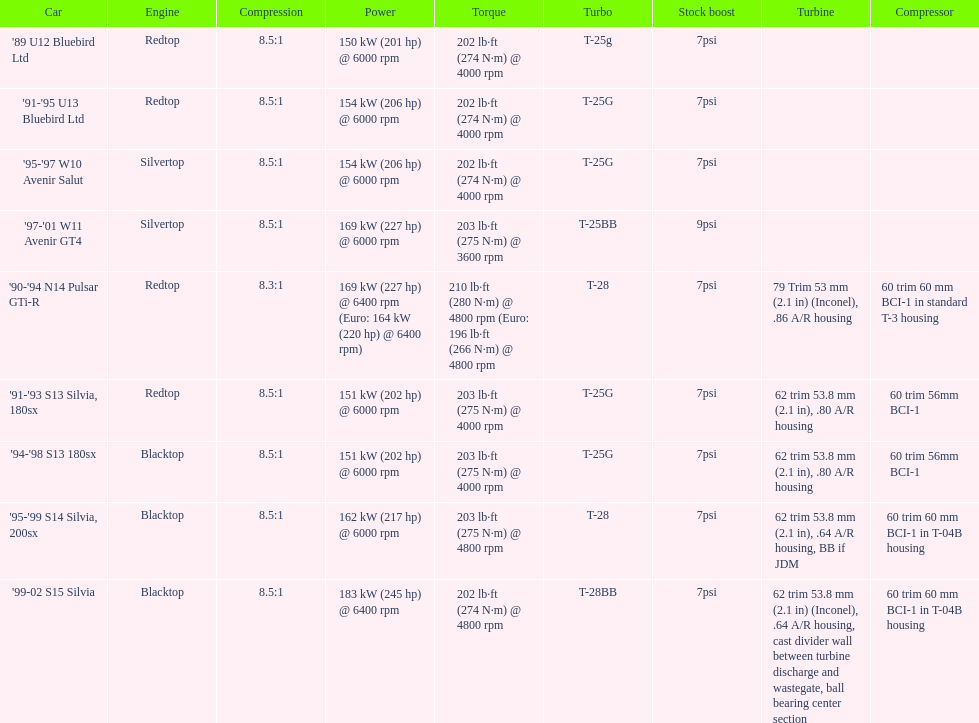For the 90-94 n14 pulsar gti-r, what is the compression specification? 8.3:1. 